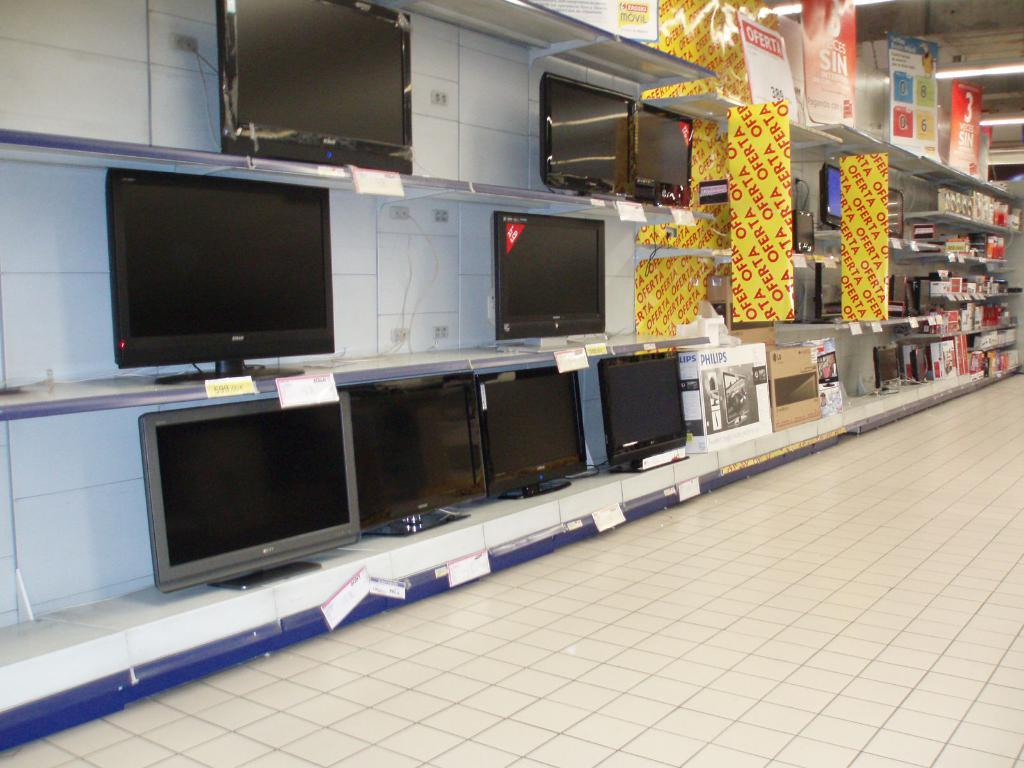What type of electronic devices are arranged in the shelves? There are televisions arranged in the shelves. What else can be seen on the right side of the image? There are other boxes on the right side. How are the lights arranged in the image? Lights are arranged on the ceiling. What direction is the farmer facing in the image? There is no farmer present in the image. 